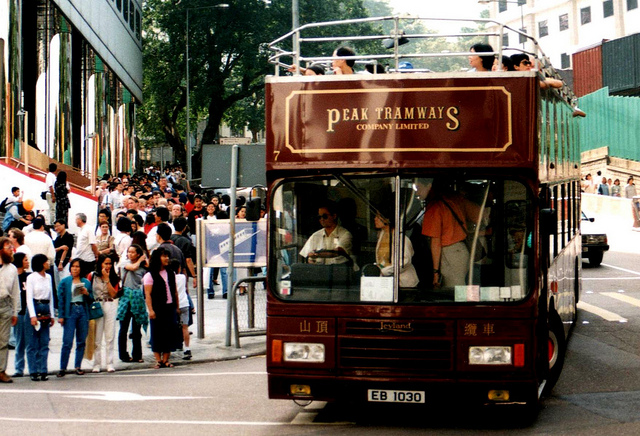Please extract the text content from this image. Peak TRAMWAY COMPANT LIMITED EB 1030 